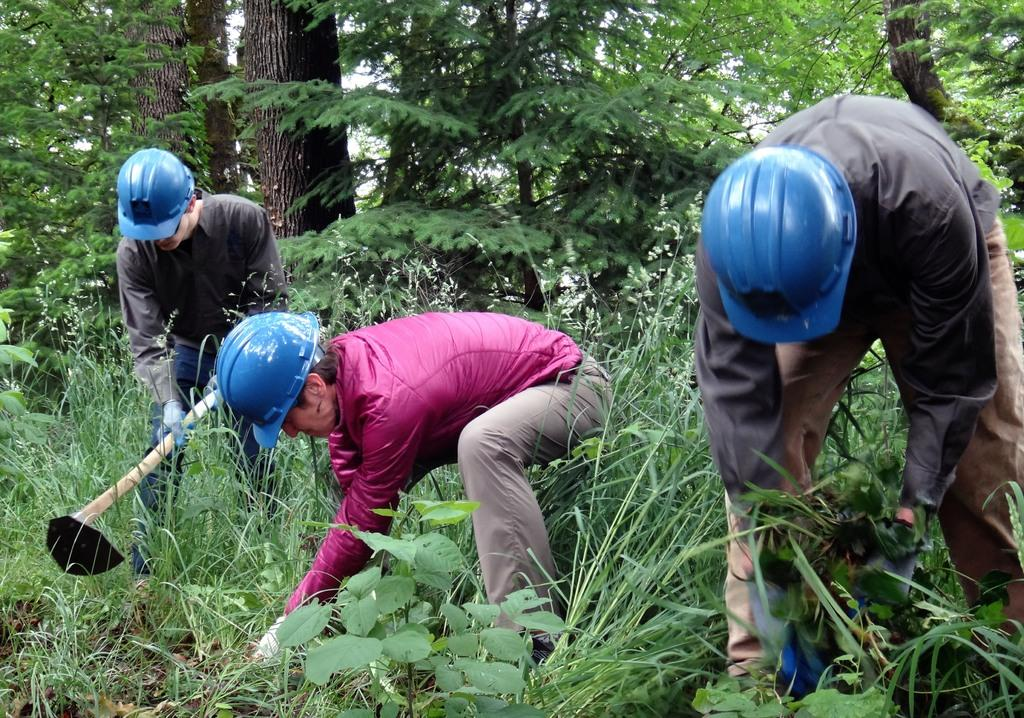How many people are in the image? There are three persons in the image. What are the people wearing on their heads? The three persons are wearing helmets. What is one person holding in the image? One person among them is holding a shovel. What can be seen in the background of the image? There are trees and grass in the background of the image. What type of bread is being used to communicate in the image? There is no bread present in the image, and bread is not used for communication. 